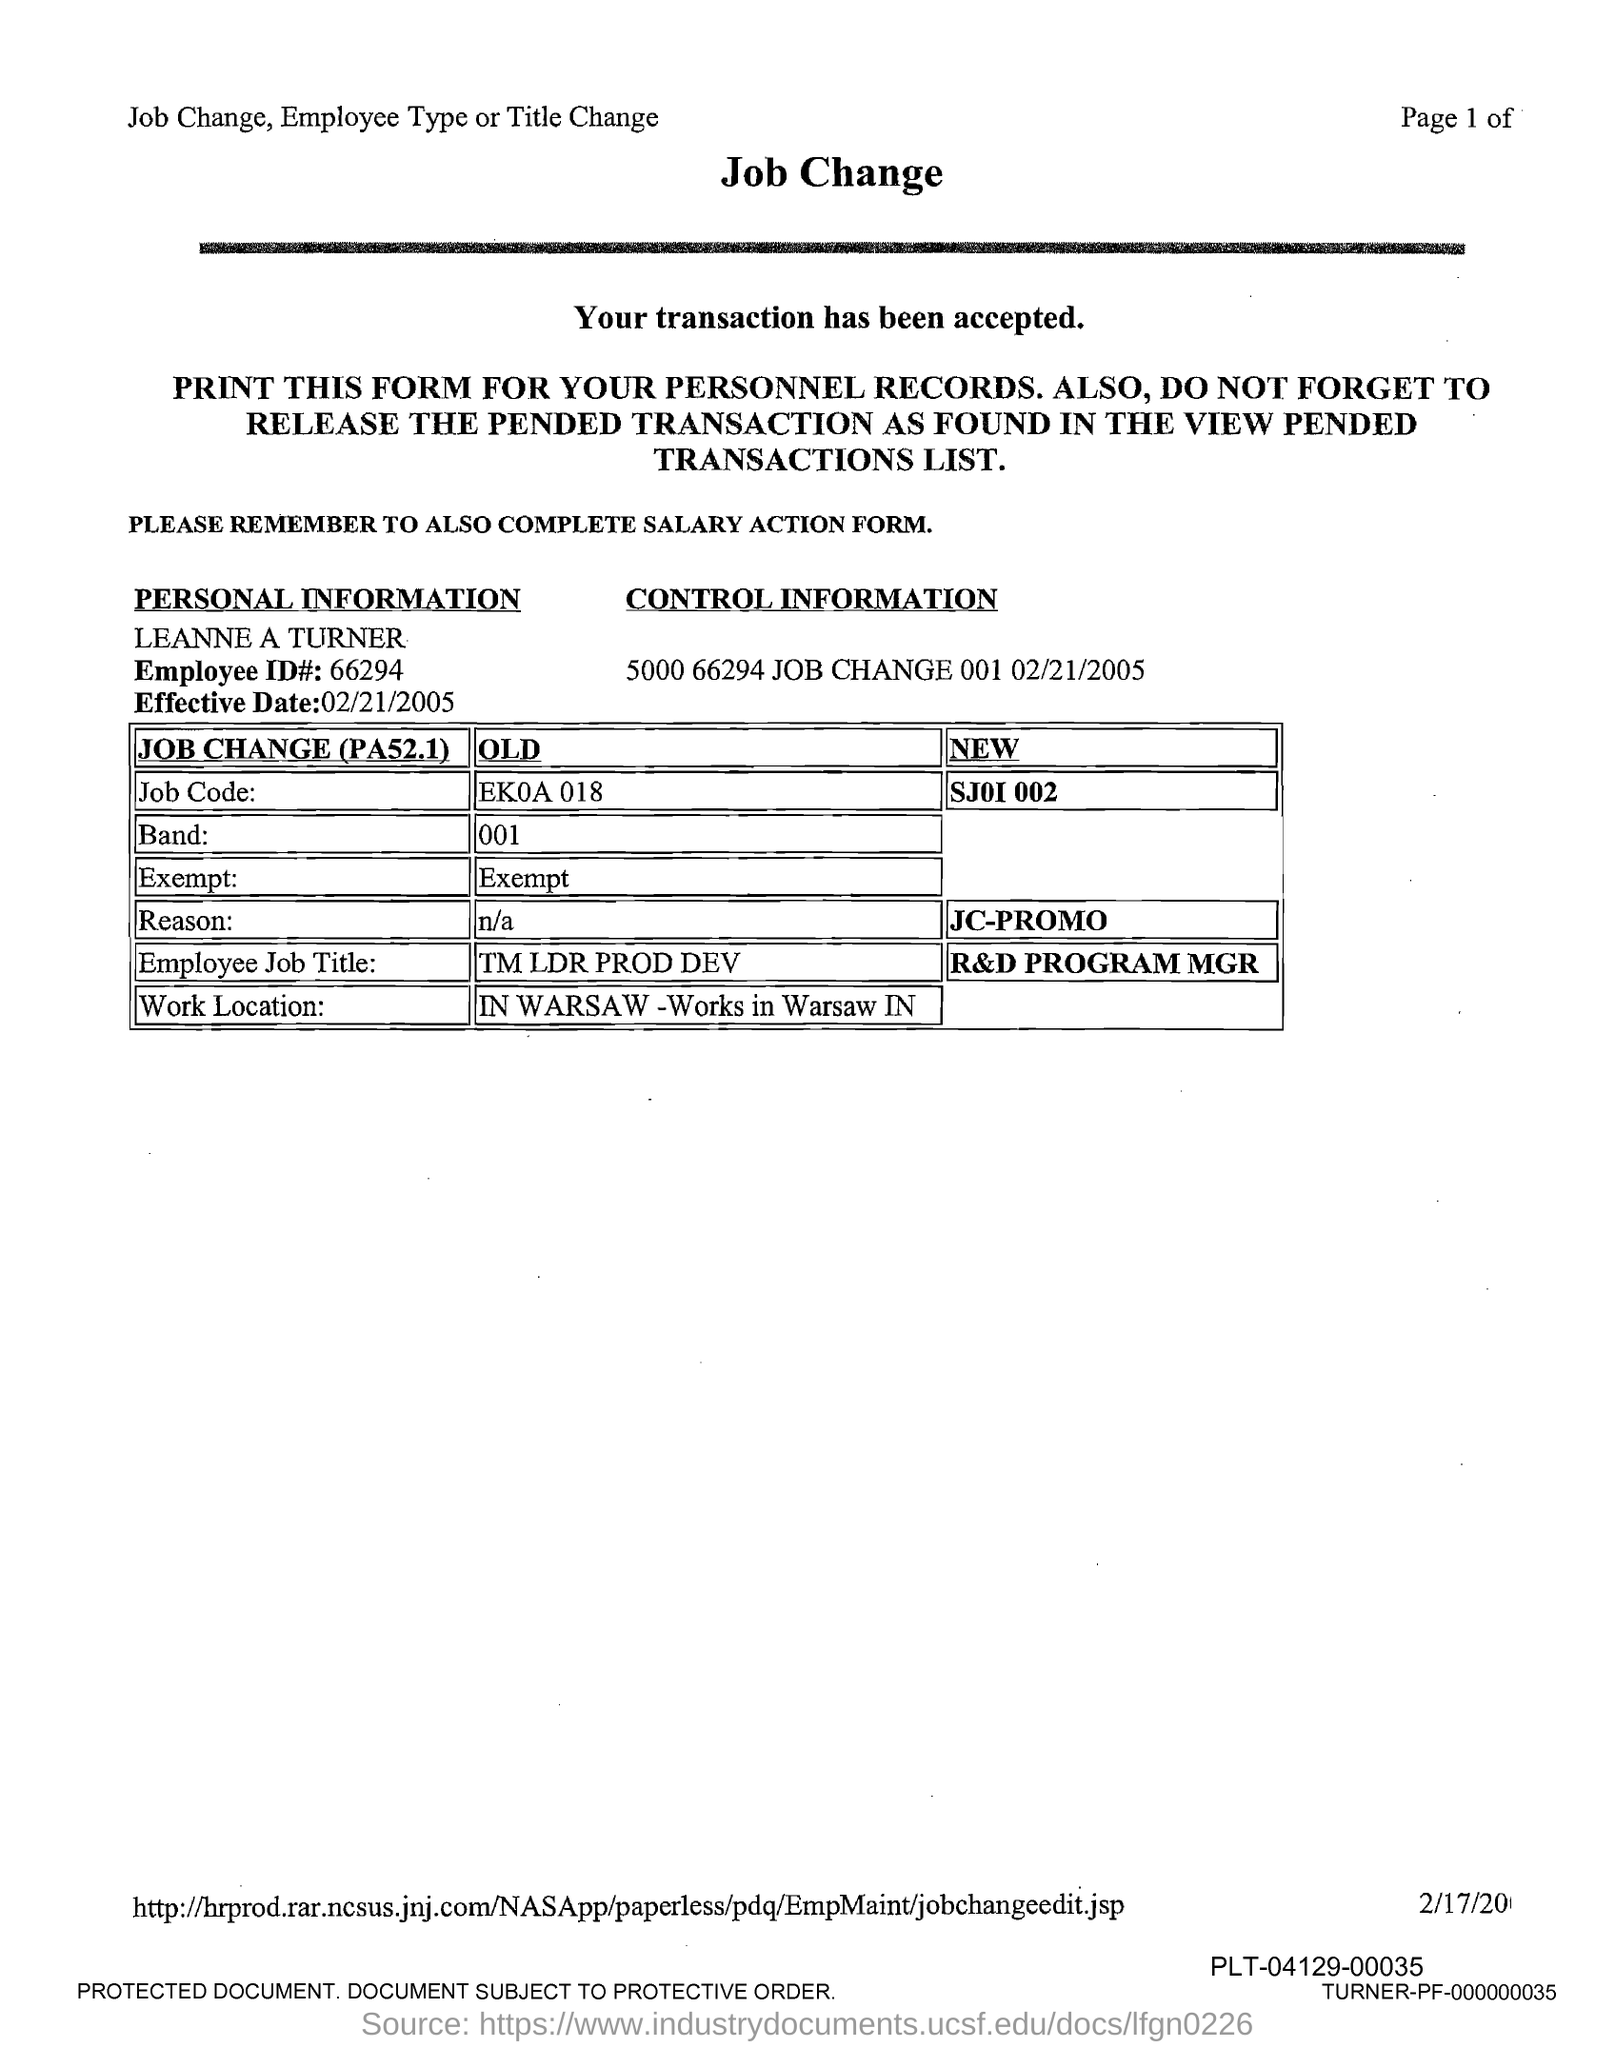Draw attention to some important aspects in this diagram. The employee named Leanne A Turner is mentioned in this form. The new employee's job title is R&D Program Manager. The work location is mentioned in this form as "WARSAW - Works in Warsaw IN.. The old job code mentioned in this form is 'ek0a 018..' Can you please provide the name of the former employee's job title mentioned? tm ldr prod dev.. 